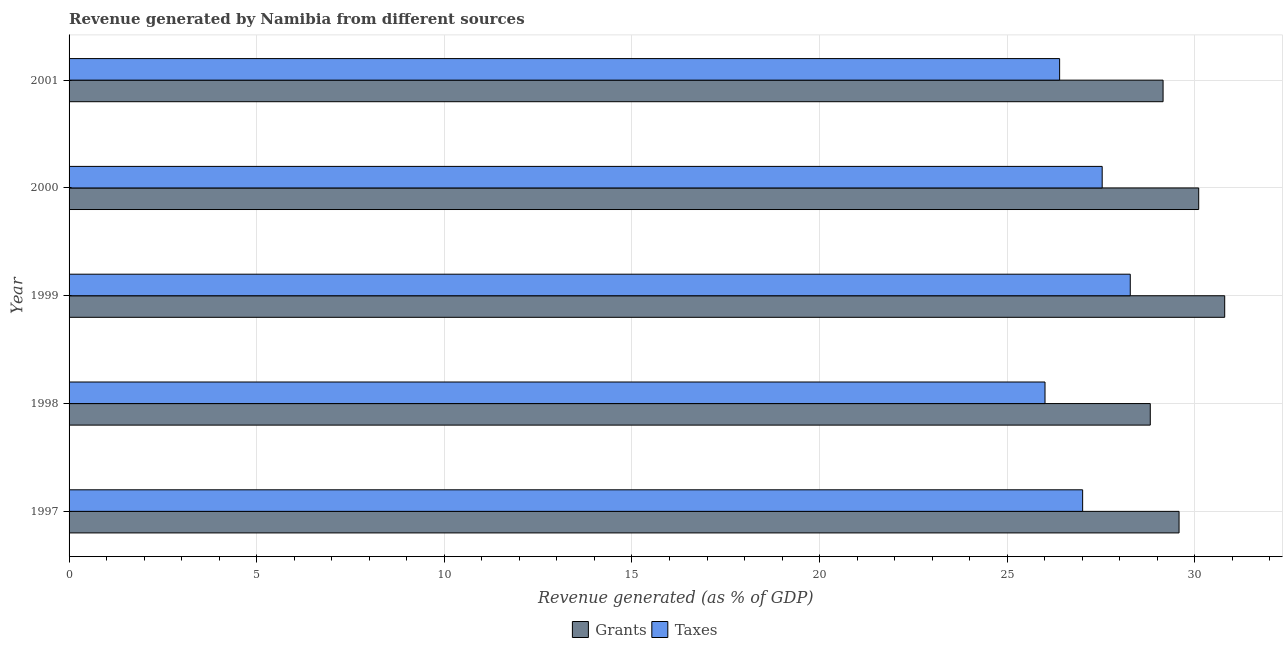How many different coloured bars are there?
Offer a very short reply. 2. How many groups of bars are there?
Give a very brief answer. 5. Are the number of bars on each tick of the Y-axis equal?
Give a very brief answer. Yes. How many bars are there on the 2nd tick from the top?
Your answer should be compact. 2. How many bars are there on the 1st tick from the bottom?
Ensure brevity in your answer.  2. What is the revenue generated by grants in 1999?
Your response must be concise. 30.79. Across all years, what is the maximum revenue generated by grants?
Offer a very short reply. 30.79. Across all years, what is the minimum revenue generated by grants?
Provide a succinct answer. 28.81. In which year was the revenue generated by taxes maximum?
Make the answer very short. 1999. What is the total revenue generated by taxes in the graph?
Offer a terse response. 135.22. What is the difference between the revenue generated by taxes in 1997 and that in 2001?
Your response must be concise. 0.61. What is the difference between the revenue generated by grants in 1998 and the revenue generated by taxes in 2001?
Provide a succinct answer. 2.42. What is the average revenue generated by taxes per year?
Your response must be concise. 27.04. In the year 1998, what is the difference between the revenue generated by grants and revenue generated by taxes?
Offer a very short reply. 2.81. In how many years, is the revenue generated by grants greater than 9 %?
Your answer should be compact. 5. What is the ratio of the revenue generated by grants in 1998 to that in 1999?
Provide a short and direct response. 0.94. Is the difference between the revenue generated by taxes in 1998 and 2001 greater than the difference between the revenue generated by grants in 1998 and 2001?
Ensure brevity in your answer.  No. What is the difference between the highest and the second highest revenue generated by grants?
Keep it short and to the point. 0.69. What is the difference between the highest and the lowest revenue generated by grants?
Provide a short and direct response. 1.98. Is the sum of the revenue generated by taxes in 1999 and 2000 greater than the maximum revenue generated by grants across all years?
Give a very brief answer. Yes. What does the 2nd bar from the top in 2000 represents?
Give a very brief answer. Grants. What does the 1st bar from the bottom in 1997 represents?
Ensure brevity in your answer.  Grants. How many years are there in the graph?
Keep it short and to the point. 5. What is the difference between two consecutive major ticks on the X-axis?
Make the answer very short. 5. Are the values on the major ticks of X-axis written in scientific E-notation?
Offer a very short reply. No. Does the graph contain grids?
Keep it short and to the point. Yes. How are the legend labels stacked?
Your answer should be compact. Horizontal. What is the title of the graph?
Keep it short and to the point. Revenue generated by Namibia from different sources. What is the label or title of the X-axis?
Make the answer very short. Revenue generated (as % of GDP). What is the label or title of the Y-axis?
Offer a terse response. Year. What is the Revenue generated (as % of GDP) in Grants in 1997?
Offer a very short reply. 29.58. What is the Revenue generated (as % of GDP) of Taxes in 1997?
Offer a very short reply. 27.01. What is the Revenue generated (as % of GDP) in Grants in 1998?
Keep it short and to the point. 28.81. What is the Revenue generated (as % of GDP) of Taxes in 1998?
Give a very brief answer. 26.01. What is the Revenue generated (as % of GDP) of Grants in 1999?
Your response must be concise. 30.79. What is the Revenue generated (as % of GDP) of Taxes in 1999?
Offer a very short reply. 28.28. What is the Revenue generated (as % of GDP) of Grants in 2000?
Keep it short and to the point. 30.1. What is the Revenue generated (as % of GDP) of Taxes in 2000?
Your answer should be very brief. 27.53. What is the Revenue generated (as % of GDP) of Grants in 2001?
Offer a very short reply. 29.15. What is the Revenue generated (as % of GDP) of Taxes in 2001?
Offer a terse response. 26.4. Across all years, what is the maximum Revenue generated (as % of GDP) of Grants?
Offer a terse response. 30.79. Across all years, what is the maximum Revenue generated (as % of GDP) in Taxes?
Your answer should be compact. 28.28. Across all years, what is the minimum Revenue generated (as % of GDP) of Grants?
Give a very brief answer. 28.81. Across all years, what is the minimum Revenue generated (as % of GDP) in Taxes?
Provide a succinct answer. 26.01. What is the total Revenue generated (as % of GDP) of Grants in the graph?
Your response must be concise. 148.44. What is the total Revenue generated (as % of GDP) in Taxes in the graph?
Offer a terse response. 135.22. What is the difference between the Revenue generated (as % of GDP) in Grants in 1997 and that in 1998?
Make the answer very short. 0.77. What is the difference between the Revenue generated (as % of GDP) in Grants in 1997 and that in 1999?
Your response must be concise. -1.22. What is the difference between the Revenue generated (as % of GDP) of Taxes in 1997 and that in 1999?
Keep it short and to the point. -1.27. What is the difference between the Revenue generated (as % of GDP) of Grants in 1997 and that in 2000?
Provide a short and direct response. -0.52. What is the difference between the Revenue generated (as % of GDP) in Taxes in 1997 and that in 2000?
Provide a short and direct response. -0.52. What is the difference between the Revenue generated (as % of GDP) in Grants in 1997 and that in 2001?
Offer a terse response. 0.43. What is the difference between the Revenue generated (as % of GDP) in Taxes in 1997 and that in 2001?
Offer a very short reply. 0.61. What is the difference between the Revenue generated (as % of GDP) in Grants in 1998 and that in 1999?
Give a very brief answer. -1.98. What is the difference between the Revenue generated (as % of GDP) of Taxes in 1998 and that in 1999?
Your answer should be compact. -2.27. What is the difference between the Revenue generated (as % of GDP) of Grants in 1998 and that in 2000?
Your response must be concise. -1.29. What is the difference between the Revenue generated (as % of GDP) of Taxes in 1998 and that in 2000?
Keep it short and to the point. -1.52. What is the difference between the Revenue generated (as % of GDP) of Grants in 1998 and that in 2001?
Your answer should be compact. -0.34. What is the difference between the Revenue generated (as % of GDP) of Taxes in 1998 and that in 2001?
Offer a terse response. -0.39. What is the difference between the Revenue generated (as % of GDP) in Grants in 1999 and that in 2000?
Provide a short and direct response. 0.69. What is the difference between the Revenue generated (as % of GDP) in Taxes in 1999 and that in 2000?
Provide a short and direct response. 0.75. What is the difference between the Revenue generated (as % of GDP) of Grants in 1999 and that in 2001?
Offer a very short reply. 1.64. What is the difference between the Revenue generated (as % of GDP) of Taxes in 1999 and that in 2001?
Make the answer very short. 1.88. What is the difference between the Revenue generated (as % of GDP) in Grants in 2000 and that in 2001?
Ensure brevity in your answer.  0.95. What is the difference between the Revenue generated (as % of GDP) of Taxes in 2000 and that in 2001?
Your answer should be compact. 1.13. What is the difference between the Revenue generated (as % of GDP) in Grants in 1997 and the Revenue generated (as % of GDP) in Taxes in 1998?
Provide a succinct answer. 3.57. What is the difference between the Revenue generated (as % of GDP) in Grants in 1997 and the Revenue generated (as % of GDP) in Taxes in 1999?
Provide a succinct answer. 1.3. What is the difference between the Revenue generated (as % of GDP) of Grants in 1997 and the Revenue generated (as % of GDP) of Taxes in 2000?
Offer a very short reply. 2.05. What is the difference between the Revenue generated (as % of GDP) in Grants in 1997 and the Revenue generated (as % of GDP) in Taxes in 2001?
Keep it short and to the point. 3.18. What is the difference between the Revenue generated (as % of GDP) in Grants in 1998 and the Revenue generated (as % of GDP) in Taxes in 1999?
Your answer should be very brief. 0.53. What is the difference between the Revenue generated (as % of GDP) of Grants in 1998 and the Revenue generated (as % of GDP) of Taxes in 2000?
Your answer should be very brief. 1.28. What is the difference between the Revenue generated (as % of GDP) of Grants in 1998 and the Revenue generated (as % of GDP) of Taxes in 2001?
Ensure brevity in your answer.  2.42. What is the difference between the Revenue generated (as % of GDP) of Grants in 1999 and the Revenue generated (as % of GDP) of Taxes in 2000?
Ensure brevity in your answer.  3.27. What is the difference between the Revenue generated (as % of GDP) in Grants in 1999 and the Revenue generated (as % of GDP) in Taxes in 2001?
Make the answer very short. 4.4. What is the difference between the Revenue generated (as % of GDP) in Grants in 2000 and the Revenue generated (as % of GDP) in Taxes in 2001?
Your answer should be very brief. 3.71. What is the average Revenue generated (as % of GDP) in Grants per year?
Your answer should be compact. 29.69. What is the average Revenue generated (as % of GDP) in Taxes per year?
Provide a short and direct response. 27.04. In the year 1997, what is the difference between the Revenue generated (as % of GDP) in Grants and Revenue generated (as % of GDP) in Taxes?
Offer a terse response. 2.57. In the year 1998, what is the difference between the Revenue generated (as % of GDP) in Grants and Revenue generated (as % of GDP) in Taxes?
Keep it short and to the point. 2.8. In the year 1999, what is the difference between the Revenue generated (as % of GDP) of Grants and Revenue generated (as % of GDP) of Taxes?
Offer a very short reply. 2.52. In the year 2000, what is the difference between the Revenue generated (as % of GDP) in Grants and Revenue generated (as % of GDP) in Taxes?
Give a very brief answer. 2.57. In the year 2001, what is the difference between the Revenue generated (as % of GDP) in Grants and Revenue generated (as % of GDP) in Taxes?
Your answer should be very brief. 2.76. What is the ratio of the Revenue generated (as % of GDP) in Grants in 1997 to that in 1998?
Keep it short and to the point. 1.03. What is the ratio of the Revenue generated (as % of GDP) in Taxes in 1997 to that in 1998?
Your response must be concise. 1.04. What is the ratio of the Revenue generated (as % of GDP) of Grants in 1997 to that in 1999?
Ensure brevity in your answer.  0.96. What is the ratio of the Revenue generated (as % of GDP) in Taxes in 1997 to that in 1999?
Your answer should be compact. 0.96. What is the ratio of the Revenue generated (as % of GDP) of Grants in 1997 to that in 2000?
Your response must be concise. 0.98. What is the ratio of the Revenue generated (as % of GDP) in Taxes in 1997 to that in 2000?
Provide a succinct answer. 0.98. What is the ratio of the Revenue generated (as % of GDP) of Grants in 1997 to that in 2001?
Provide a succinct answer. 1.01. What is the ratio of the Revenue generated (as % of GDP) of Taxes in 1997 to that in 2001?
Your answer should be very brief. 1.02. What is the ratio of the Revenue generated (as % of GDP) in Grants in 1998 to that in 1999?
Offer a terse response. 0.94. What is the ratio of the Revenue generated (as % of GDP) in Taxes in 1998 to that in 1999?
Provide a short and direct response. 0.92. What is the ratio of the Revenue generated (as % of GDP) of Grants in 1998 to that in 2000?
Give a very brief answer. 0.96. What is the ratio of the Revenue generated (as % of GDP) in Taxes in 1998 to that in 2000?
Give a very brief answer. 0.94. What is the ratio of the Revenue generated (as % of GDP) in Grants in 1998 to that in 2001?
Give a very brief answer. 0.99. What is the ratio of the Revenue generated (as % of GDP) of Grants in 1999 to that in 2000?
Your response must be concise. 1.02. What is the ratio of the Revenue generated (as % of GDP) in Taxes in 1999 to that in 2000?
Make the answer very short. 1.03. What is the ratio of the Revenue generated (as % of GDP) in Grants in 1999 to that in 2001?
Offer a terse response. 1.06. What is the ratio of the Revenue generated (as % of GDP) of Taxes in 1999 to that in 2001?
Keep it short and to the point. 1.07. What is the ratio of the Revenue generated (as % of GDP) in Grants in 2000 to that in 2001?
Ensure brevity in your answer.  1.03. What is the ratio of the Revenue generated (as % of GDP) of Taxes in 2000 to that in 2001?
Your answer should be compact. 1.04. What is the difference between the highest and the second highest Revenue generated (as % of GDP) of Grants?
Make the answer very short. 0.69. What is the difference between the highest and the second highest Revenue generated (as % of GDP) in Taxes?
Provide a succinct answer. 0.75. What is the difference between the highest and the lowest Revenue generated (as % of GDP) in Grants?
Offer a terse response. 1.98. What is the difference between the highest and the lowest Revenue generated (as % of GDP) of Taxes?
Keep it short and to the point. 2.27. 